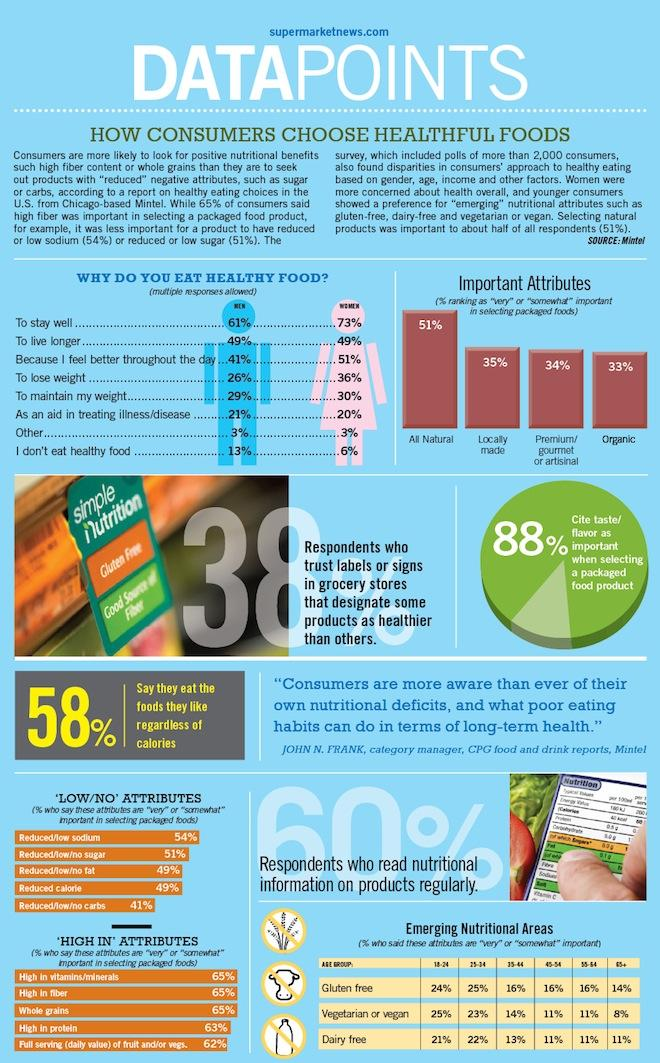Indicate a few pertinent items in this graphic. Only 12% of the consumers surveyed did not consider taste and flavor to be important factors in their purchasing decisions. Locally made packaged foods are the second most important attribute that consumers consider when making their selection, after safety and before taste and nutrition. According to the survey, nearly 40% of people do not regularly read the nutritional information on products they consume. 